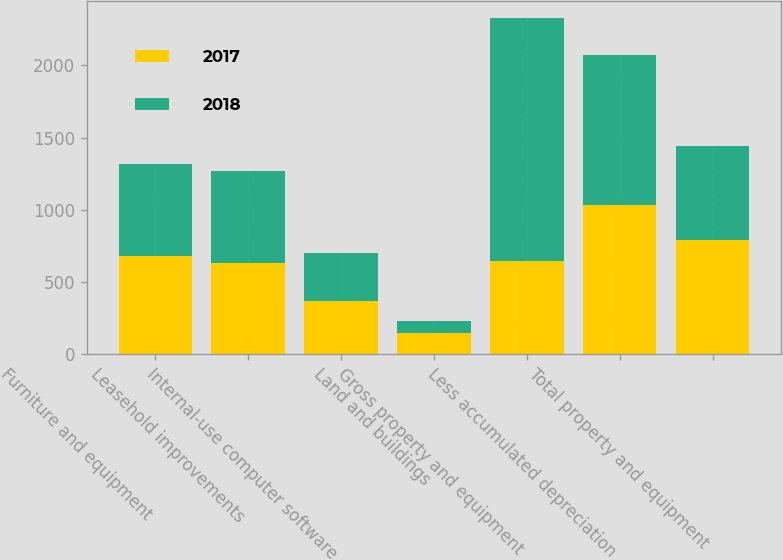<chart> <loc_0><loc_0><loc_500><loc_500><stacked_bar_chart><ecel><fcel>Furniture and equipment<fcel>Leasehold improvements<fcel>Internal-use computer software<fcel>Land and buildings<fcel>Gross property and equipment<fcel>Less accumulated depreciation<fcel>Total property and equipment<nl><fcel>2017<fcel>681.7<fcel>629<fcel>368.5<fcel>146.6<fcel>641.5<fcel>1034.9<fcel>790.9<nl><fcel>2018<fcel>634.8<fcel>641.5<fcel>331.3<fcel>79<fcel>1686.6<fcel>1036.2<fcel>650.4<nl></chart> 